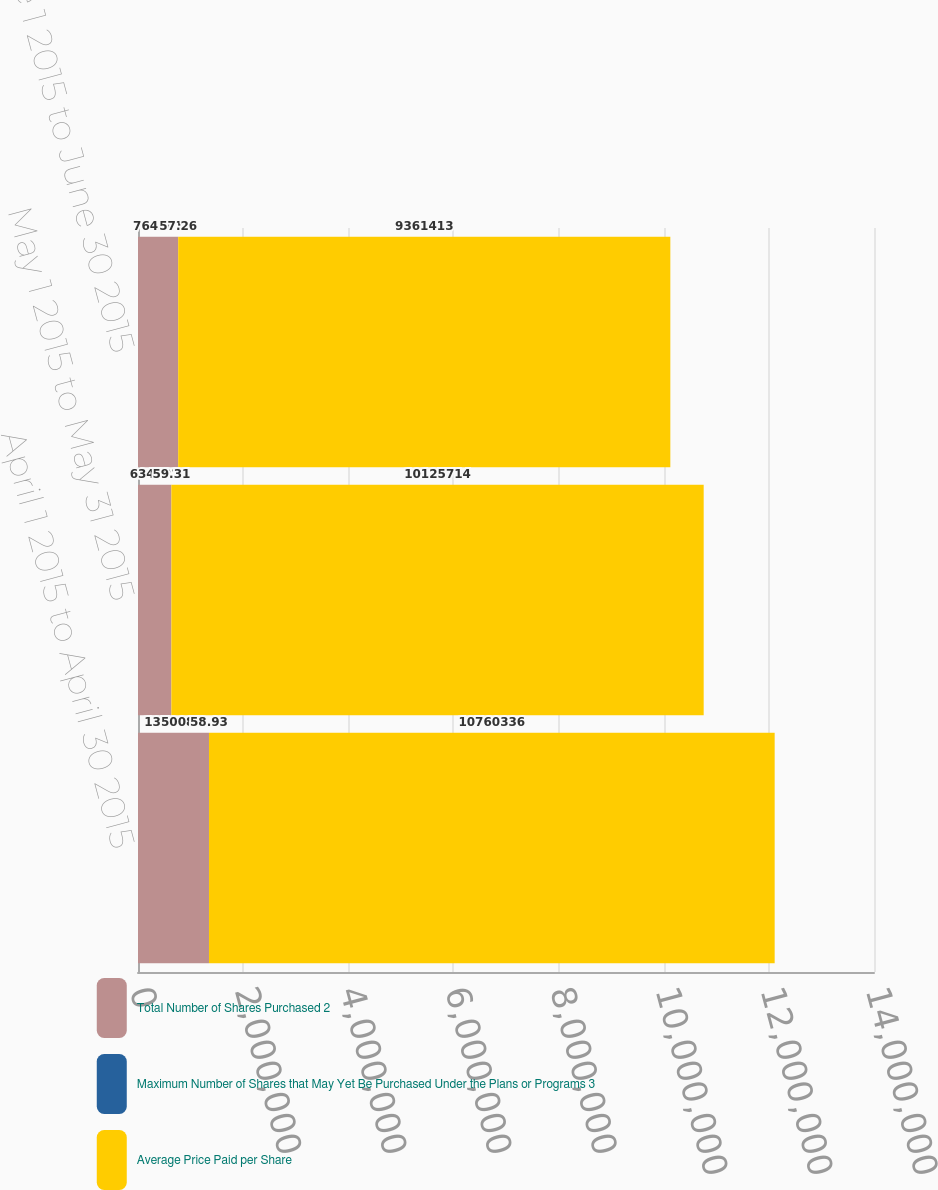Convert chart to OTSL. <chart><loc_0><loc_0><loc_500><loc_500><stacked_bar_chart><ecel><fcel>April 1 2015 to April 30 2015<fcel>May 1 2015 to May 31 2015<fcel>June 1 2015 to June 30 2015<nl><fcel>Total Number of Shares Purchased 2<fcel>1.35009e+06<fcel>634622<fcel>764301<nl><fcel>Maximum Number of Shares that May Yet Be Purchased Under the Plans or Programs 3<fcel>58.93<fcel>59.31<fcel>57.26<nl><fcel>Average Price Paid per Share<fcel>1.07603e+07<fcel>1.01257e+07<fcel>9.36141e+06<nl></chart> 